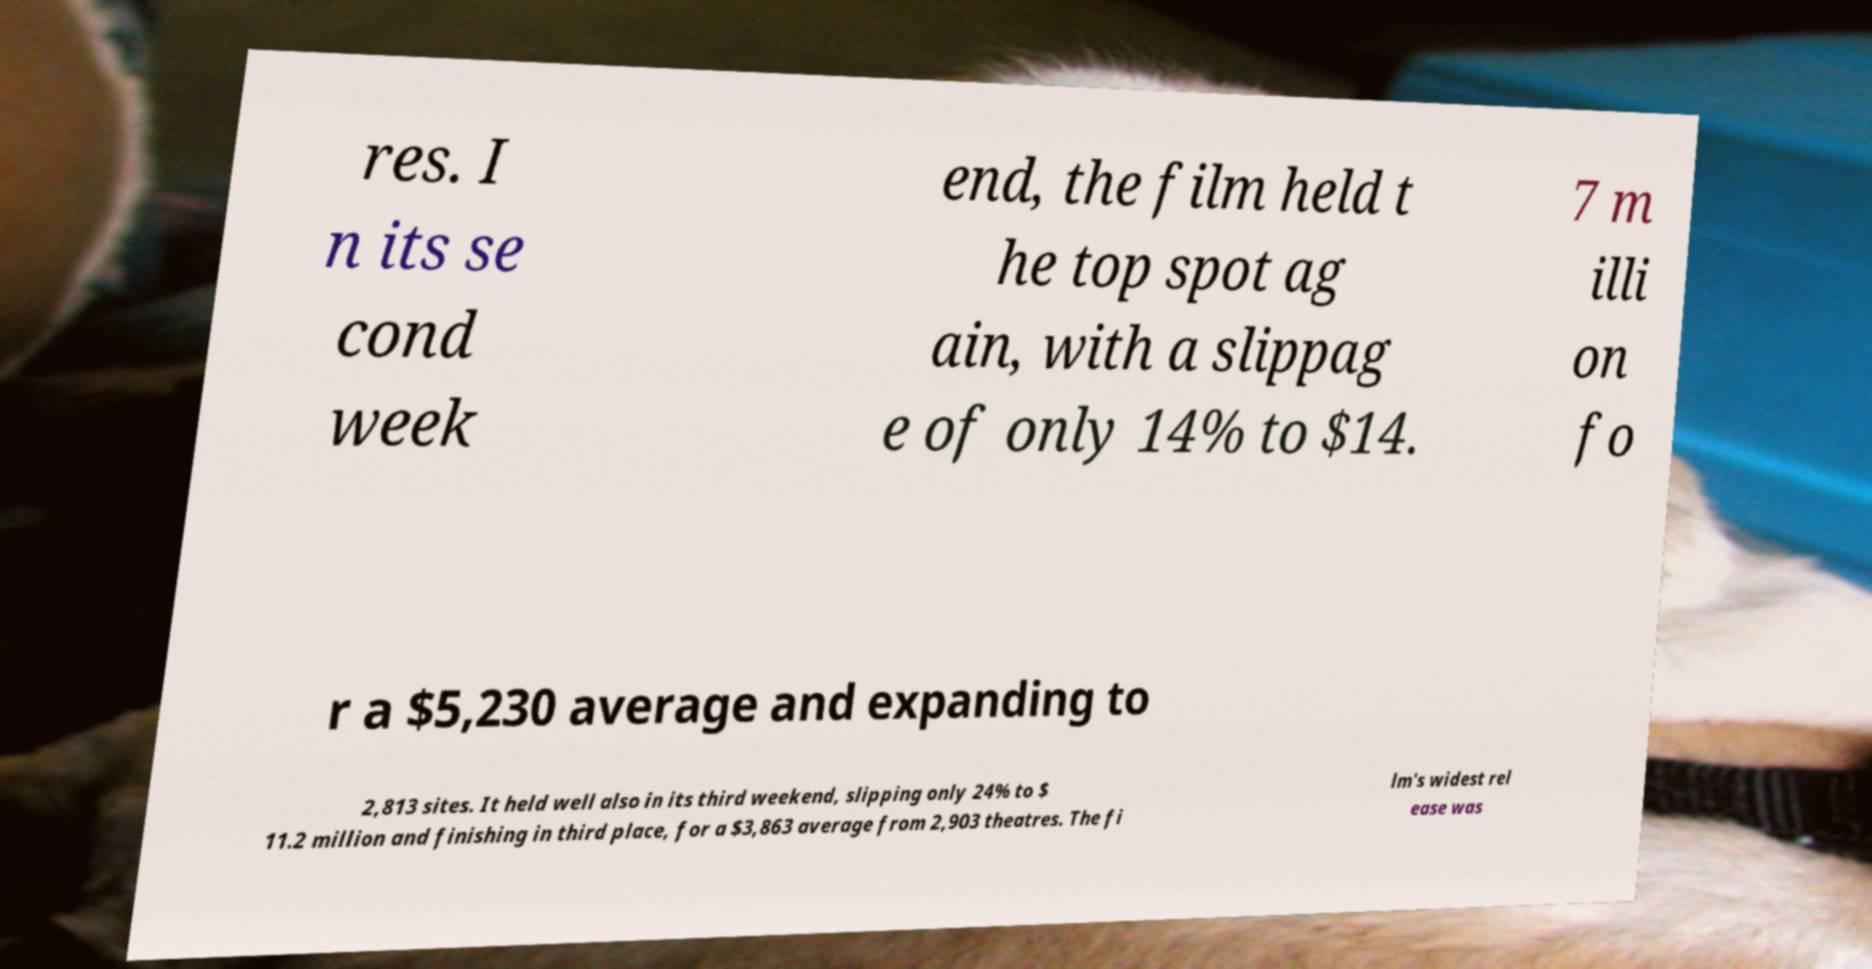Could you assist in decoding the text presented in this image and type it out clearly? res. I n its se cond week end, the film held t he top spot ag ain, with a slippag e of only 14% to $14. 7 m illi on fo r a $5,230 average and expanding to 2,813 sites. It held well also in its third weekend, slipping only 24% to $ 11.2 million and finishing in third place, for a $3,863 average from 2,903 theatres. The fi lm's widest rel ease was 